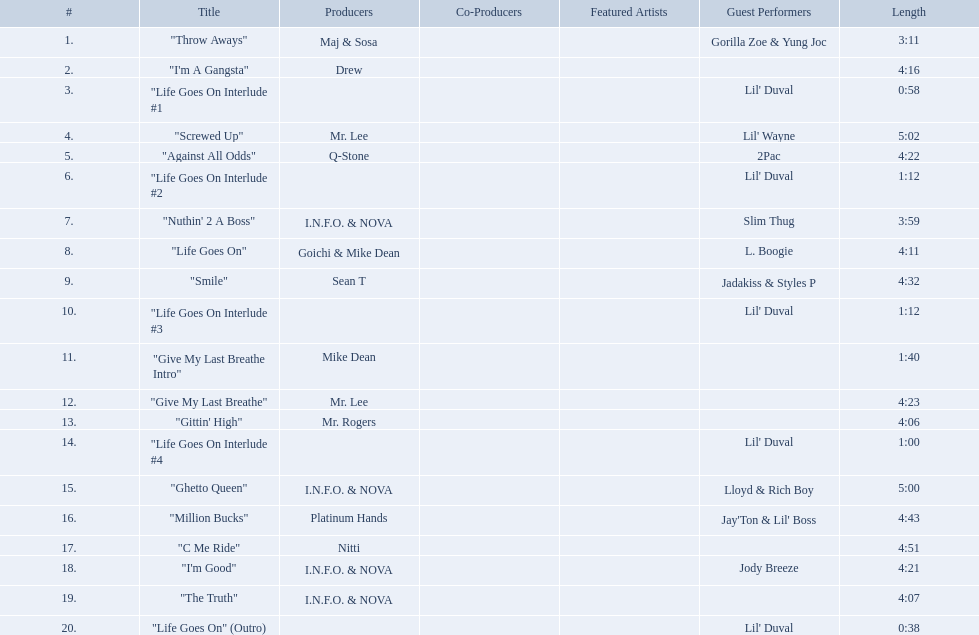What are the song lengths of all the songs on the album? 3:11, 4:16, 0:58, 5:02, 4:22, 1:12, 3:59, 4:11, 4:32, 1:12, 1:40, 4:23, 4:06, 1:00, 5:00, 4:43, 4:51, 4:21, 4:07, 0:38. Which is the longest of these? 5:02. Which tracks are longer than 4.00? "I'm A Gangsta", "Screwed Up", "Against All Odds", "Life Goes On", "Smile", "Give My Last Breathe", "Gittin' High", "Ghetto Queen", "Million Bucks", "C Me Ride", "I'm Good", "The Truth". Of those, which tracks are longer than 4.30? "Screwed Up", "Smile", "Ghetto Queen", "Million Bucks", "C Me Ride". Of those, which tracks are 5.00 or longer? "Screwed Up", "Ghetto Queen". Of those, which one is the longest? "Screwed Up". How long is that track? 5:02. Can you give me this table in json format? {'header': ['#', 'Title', 'Producers', 'Co-Producers', 'Featured Artists', 'Guest Performers', 'Length'], 'rows': [['1.', '"Throw Aways"', 'Maj & Sosa', '', '', 'Gorilla Zoe & Yung Joc', '3:11'], ['2.', '"I\'m A Gangsta"', 'Drew', '', '', '', '4:16'], ['3.', '"Life Goes On Interlude #1', '', '', '', "Lil' Duval", '0:58'], ['4.', '"Screwed Up"', 'Mr. Lee', '', '', "Lil' Wayne", '5:02'], ['5.', '"Against All Odds"', 'Q-Stone', '', '', '2Pac', '4:22'], ['6.', '"Life Goes On Interlude #2', '', '', '', "Lil' Duval", '1:12'], ['7.', '"Nuthin\' 2 A Boss"', 'I.N.F.O. & NOVA', '', '', 'Slim Thug', '3:59'], ['8.', '"Life Goes On"', 'Goichi & Mike Dean', '', '', 'L. Boogie', '4:11'], ['9.', '"Smile"', 'Sean T', '', '', 'Jadakiss & Styles P', '4:32'], ['10.', '"Life Goes On Interlude #3', '', '', '', "Lil' Duval", '1:12'], ['11.', '"Give My Last Breathe Intro"', 'Mike Dean', '', '', '', '1:40'], ['12.', '"Give My Last Breathe"', 'Mr. Lee', '', '', '', '4:23'], ['13.', '"Gittin\' High"', 'Mr. Rogers', '', '', '', '4:06'], ['14.', '"Life Goes On Interlude #4', '', '', '', "Lil' Duval", '1:00'], ['15.', '"Ghetto Queen"', 'I.N.F.O. & NOVA', '', '', 'Lloyd & Rich Boy', '5:00'], ['16.', '"Million Bucks"', 'Platinum Hands', '', '', "Jay'Ton & Lil' Boss", '4:43'], ['17.', '"C Me Ride"', 'Nitti', '', '', '', '4:51'], ['18.', '"I\'m Good"', 'I.N.F.O. & NOVA', '', '', 'Jody Breeze', '4:21'], ['19.', '"The Truth"', 'I.N.F.O. & NOVA', '', '', '', '4:07'], ['20.', '"Life Goes On" (Outro)', '', '', '', "Lil' Duval", '0:38']]} 